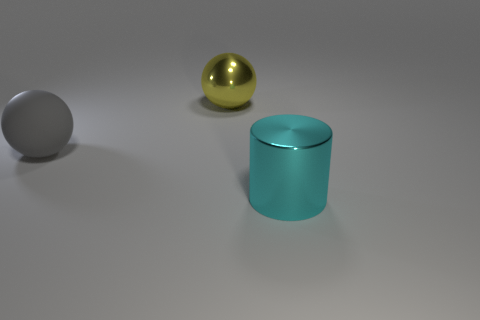Add 1 large purple cubes. How many objects exist? 4 Subtract all cylinders. How many objects are left? 2 Subtract 0 brown cubes. How many objects are left? 3 Subtract all cyan objects. Subtract all gray things. How many objects are left? 1 Add 2 big yellow shiny balls. How many big yellow shiny balls are left? 3 Add 1 big green metal blocks. How many big green metal blocks exist? 1 